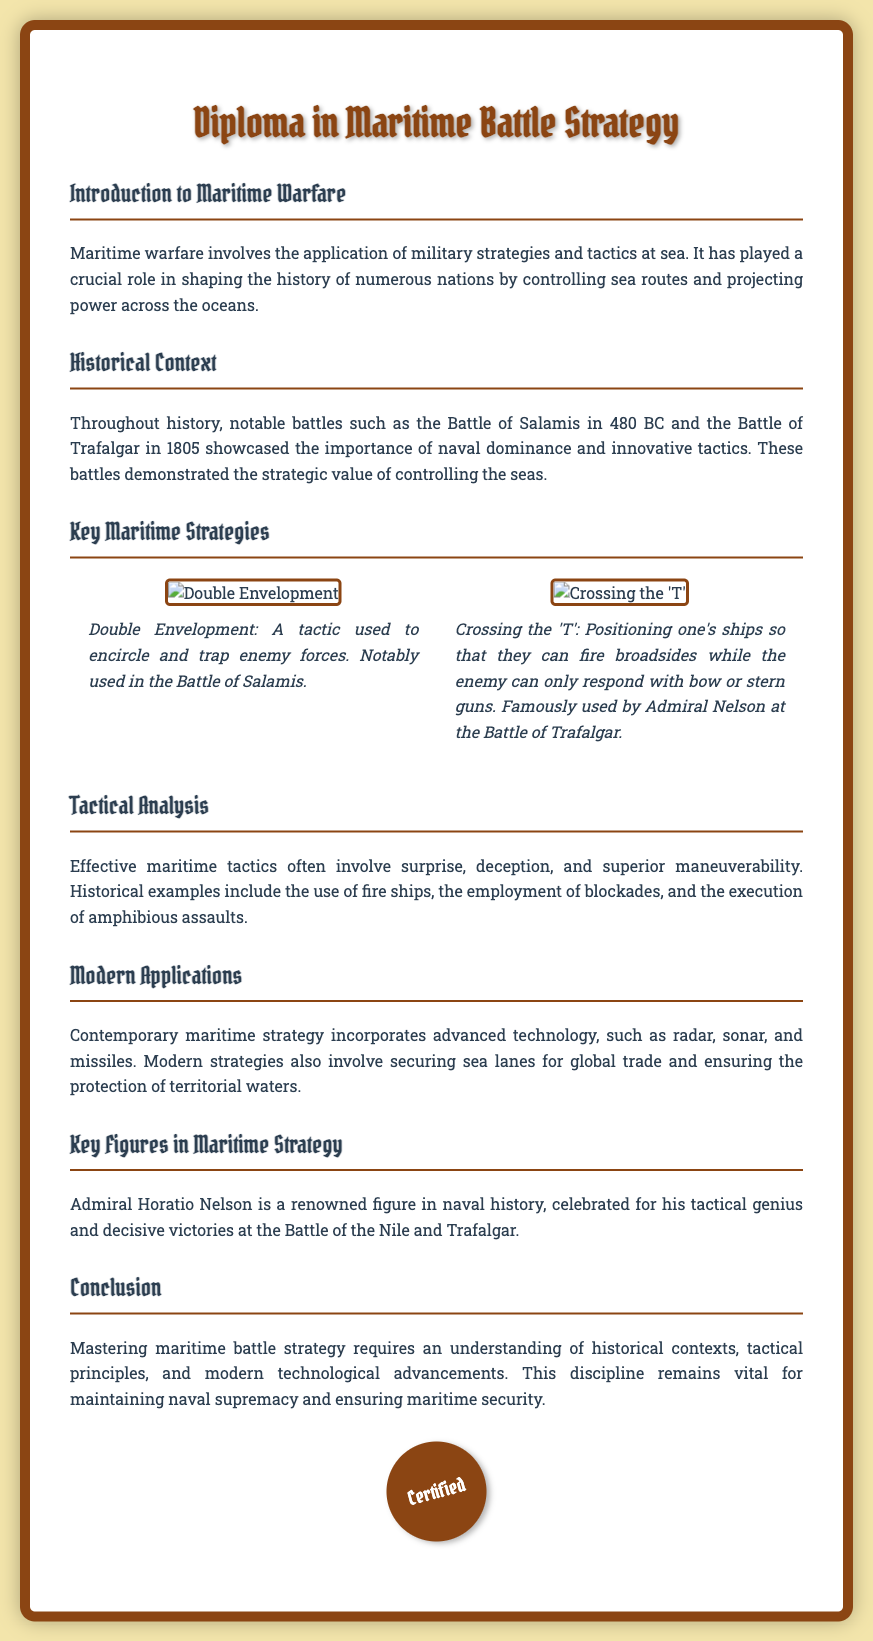What is the title of the diploma? The title of the diploma is stated prominently at the top of the document.
Answer: Diploma in Maritime Battle Strategy Who is a key figure in maritime strategy mentioned in the document? The document highlights notable individuals who have contributed to maritime tactics.
Answer: Admiral Horatio Nelson What historical battle is referenced for the tactic of Double Envelopment? The document includes key battles where certain strategies were applied.
Answer: Battle of Salamis Which technology is mentioned as part of modern maritime strategy? The document discusses contemporary advancements that influence maritime tactics.
Answer: Radar What year was the Battle of Trafalgar? The document provides specific dates for significant maritime confrontations.
Answer: 1805 What is a major tactic discussed under Key Maritime Strategies? The document lists several tactics and their applications in maritime battles.
Answer: Crossing the 'T' What principle is highlighted in the Tactical Analysis section? The document outlines effective approaches within maritime tactics.
Answer: Surprise How many diagrams are provided in the Key Maritime Strategies section? The document visually represents tactics, which can be counted.
Answer: 2 